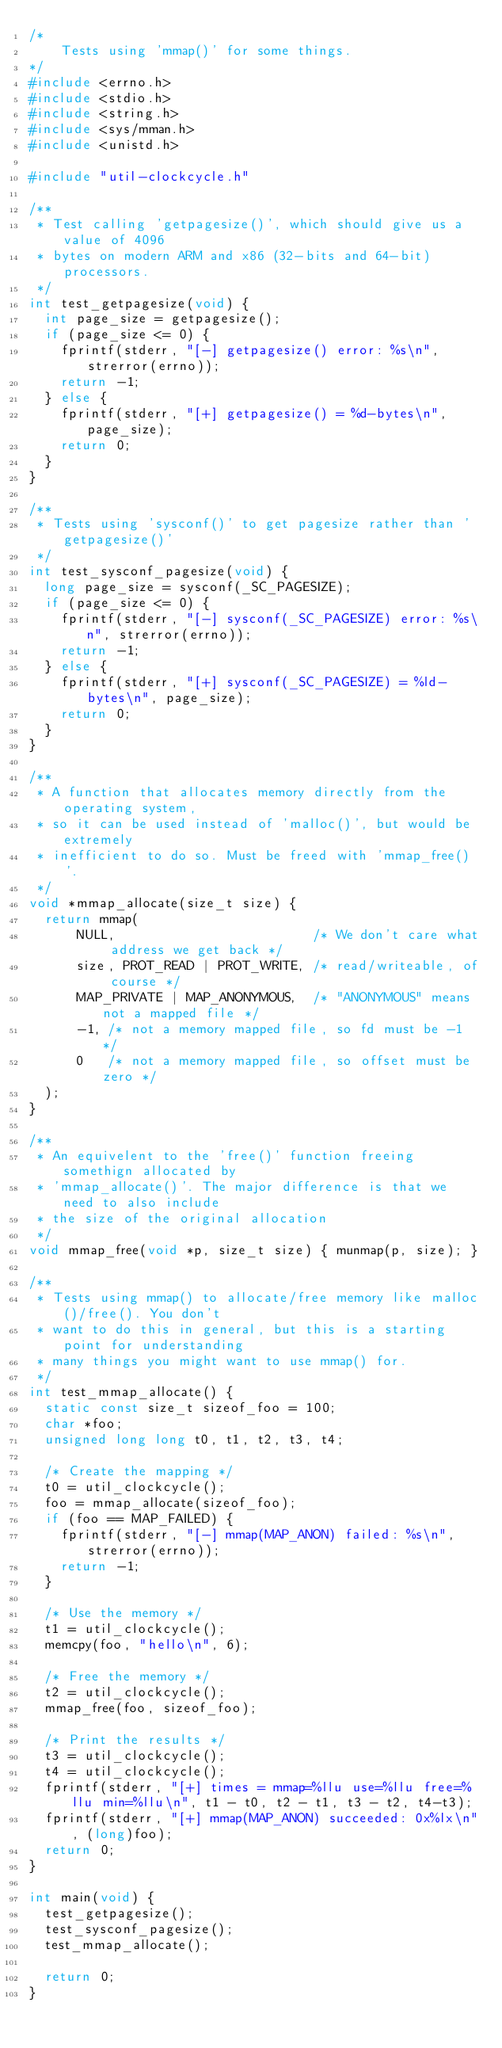<code> <loc_0><loc_0><loc_500><loc_500><_C_>/*
    Tests using 'mmap()' for some things.
*/
#include <errno.h>
#include <stdio.h>
#include <string.h>
#include <sys/mman.h>
#include <unistd.h>

#include "util-clockcycle.h"

/**
 * Test calling 'getpagesize()', which should give us a value of 4096
 * bytes on modern ARM and x86 (32-bits and 64-bit) processors.
 */
int test_getpagesize(void) {
  int page_size = getpagesize();
  if (page_size <= 0) {
    fprintf(stderr, "[-] getpagesize() error: %s\n", strerror(errno));
    return -1;
  } else {
    fprintf(stderr, "[+] getpagesize() = %d-bytes\n", page_size);
    return 0;
  }
}

/**
 * Tests using 'sysconf()' to get pagesize rather than 'getpagesize()'
 */
int test_sysconf_pagesize(void) {
  long page_size = sysconf(_SC_PAGESIZE);
  if (page_size <= 0) {
    fprintf(stderr, "[-] sysconf(_SC_PAGESIZE) error: %s\n", strerror(errno));
    return -1;
  } else {
    fprintf(stderr, "[+] sysconf(_SC_PAGESIZE) = %ld-bytes\n", page_size);
    return 0;
  }
}

/**
 * A function that allocates memory directly from the operating system,
 * so it can be used instead of 'malloc()', but would be extremely
 * inefficient to do so. Must be freed with 'mmap_free()'.
 */
void *mmap_allocate(size_t size) {
  return mmap(
      NULL,                         /* We don't care what address we get back */
      size, PROT_READ | PROT_WRITE, /* read/writeable, of course */
      MAP_PRIVATE | MAP_ANONYMOUS,  /* "ANONYMOUS" means not a mapped file */
      -1, /* not a memory mapped file, so fd must be -1 */
      0   /* not a memory mapped file, so offset must be zero */
  );
}

/**
 * An equivelent to the 'free()' function freeing somethign allocated by
 * 'mmap_allocate()'. The major difference is that we need to also include
 * the size of the original allocation
 */
void mmap_free(void *p, size_t size) { munmap(p, size); }

/**
 * Tests using mmap() to allocate/free memory like malloc()/free(). You don't
 * want to do this in general, but this is a starting point for understanding
 * many things you might want to use mmap() for.
 */
int test_mmap_allocate() {
  static const size_t sizeof_foo = 100;
  char *foo;
  unsigned long long t0, t1, t2, t3, t4;

  /* Create the mapping */
  t0 = util_clockcycle();
  foo = mmap_allocate(sizeof_foo);
  if (foo == MAP_FAILED) {
    fprintf(stderr, "[-] mmap(MAP_ANON) failed: %s\n", strerror(errno));
    return -1;
  }

  /* Use the memory */
  t1 = util_clockcycle();
  memcpy(foo, "hello\n", 6);

  /* Free the memory */
  t2 = util_clockcycle();
  mmap_free(foo, sizeof_foo);

  /* Print the results */
  t3 = util_clockcycle();
  t4 = util_clockcycle();
  fprintf(stderr, "[+] times = mmap=%llu use=%llu free=%llu min=%llu\n", t1 - t0, t2 - t1, t3 - t2, t4-t3);
  fprintf(stderr, "[+] mmap(MAP_ANON) succeeded: 0x%lx\n", (long)foo);
  return 0;
}

int main(void) {
  test_getpagesize();
  test_sysconf_pagesize();
  test_mmap_allocate();

  return 0;
}
</code> 